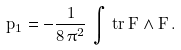<formula> <loc_0><loc_0><loc_500><loc_500>p _ { 1 } = - \frac { 1 } { 8 \, \pi ^ { 2 } } \, \int \, t r \, F \wedge F \, .</formula> 